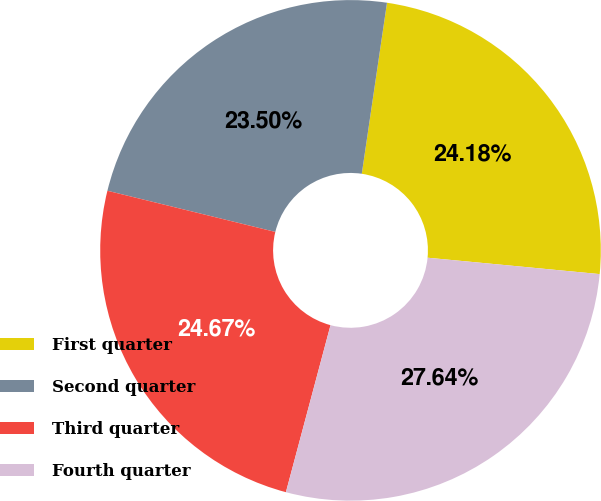Convert chart to OTSL. <chart><loc_0><loc_0><loc_500><loc_500><pie_chart><fcel>First quarter<fcel>Second quarter<fcel>Third quarter<fcel>Fourth quarter<nl><fcel>24.18%<fcel>23.5%<fcel>24.67%<fcel>27.64%<nl></chart> 